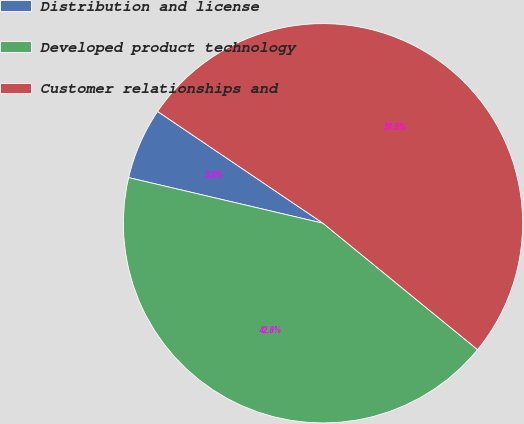<chart> <loc_0><loc_0><loc_500><loc_500><pie_chart><fcel>Distribution and license<fcel>Developed product technology<fcel>Customer relationships and<nl><fcel>5.79%<fcel>42.76%<fcel>51.45%<nl></chart> 